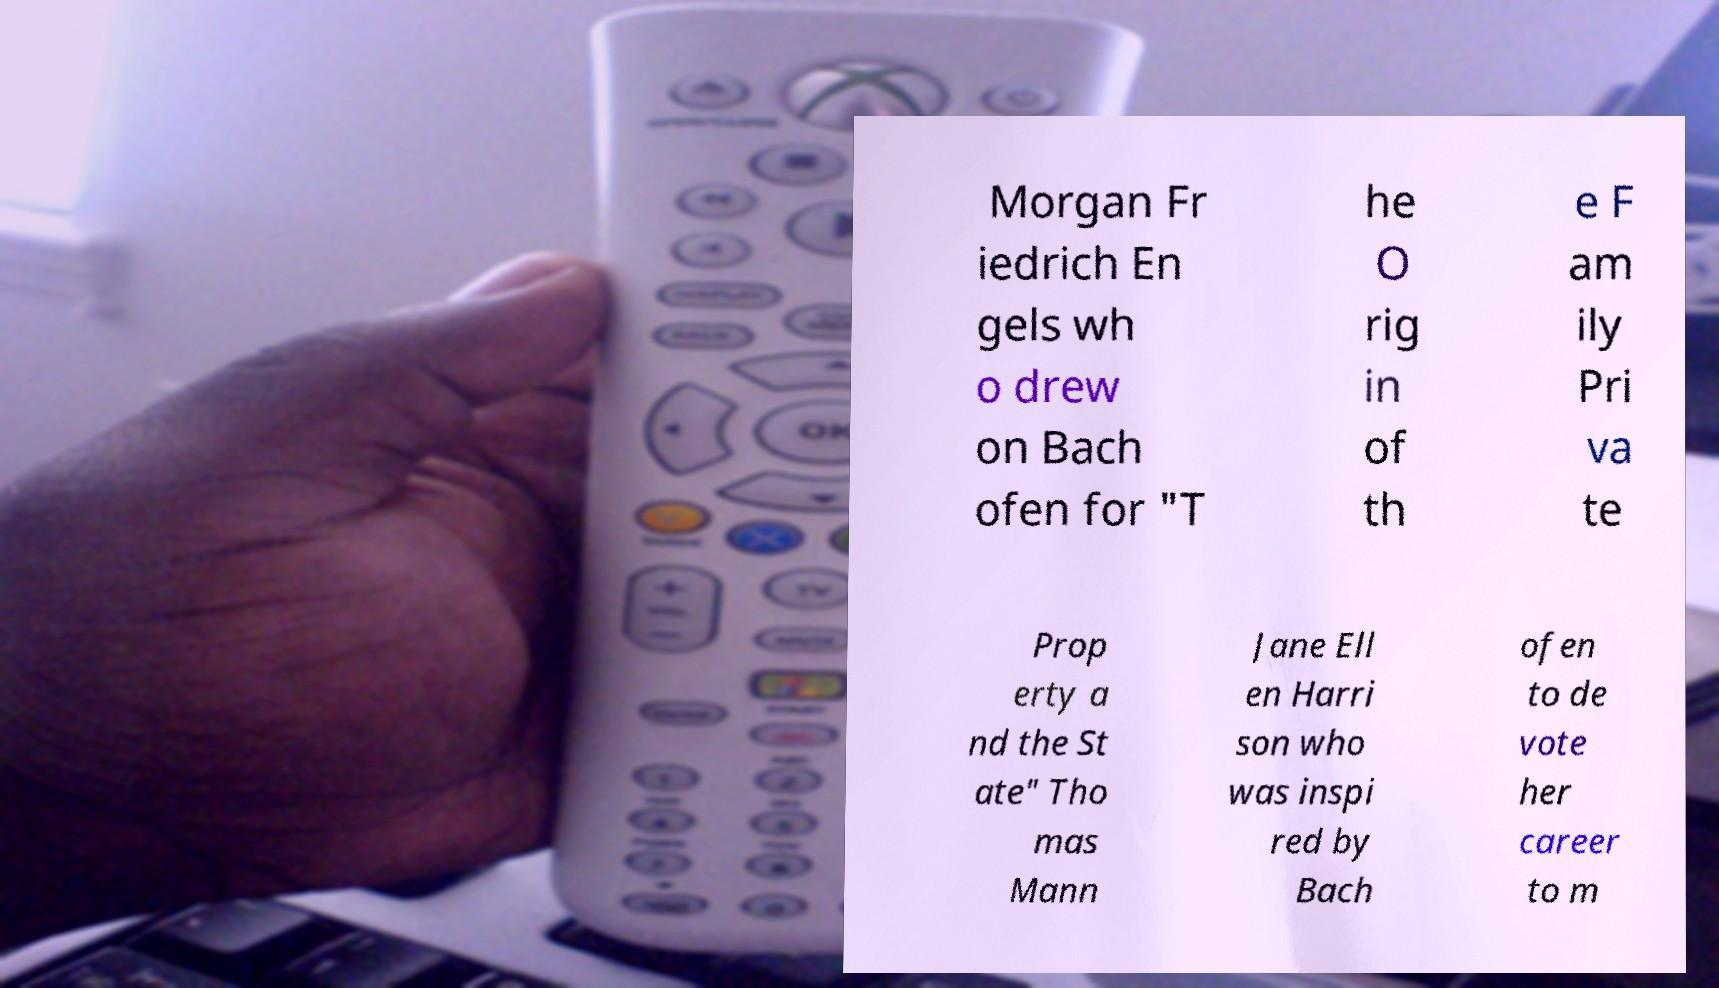What messages or text are displayed in this image? I need them in a readable, typed format. Morgan Fr iedrich En gels wh o drew on Bach ofen for "T he O rig in of th e F am ily Pri va te Prop erty a nd the St ate" Tho mas Mann Jane Ell en Harri son who was inspi red by Bach ofen to de vote her career to m 